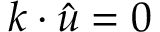<formula> <loc_0><loc_0><loc_500><loc_500>\boldsymbol k \cdot \hat { \boldsymbol u } = 0</formula> 